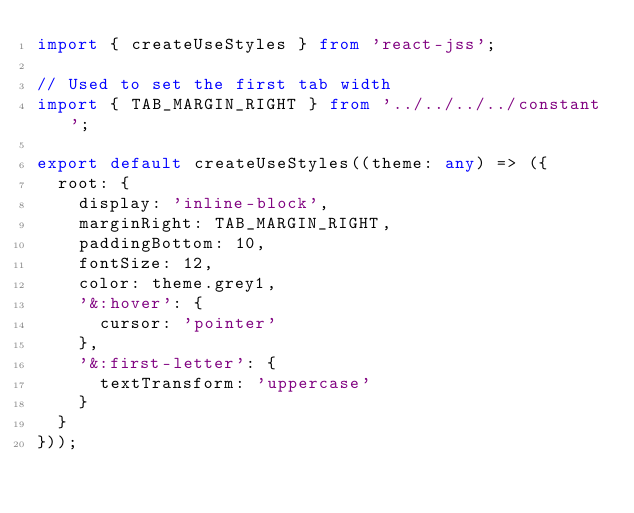Convert code to text. <code><loc_0><loc_0><loc_500><loc_500><_TypeScript_>import { createUseStyles } from 'react-jss';

// Used to set the first tab width
import { TAB_MARGIN_RIGHT } from '../../../../constant';

export default createUseStyles((theme: any) => ({
  root: {
    display: 'inline-block',
    marginRight: TAB_MARGIN_RIGHT,
    paddingBottom: 10,
    fontSize: 12,
    color: theme.grey1,
    '&:hover': {
      cursor: 'pointer'
    },
    '&:first-letter': {
      textTransform: 'uppercase'
    }
  }
}));
</code> 